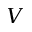<formula> <loc_0><loc_0><loc_500><loc_500>V</formula> 